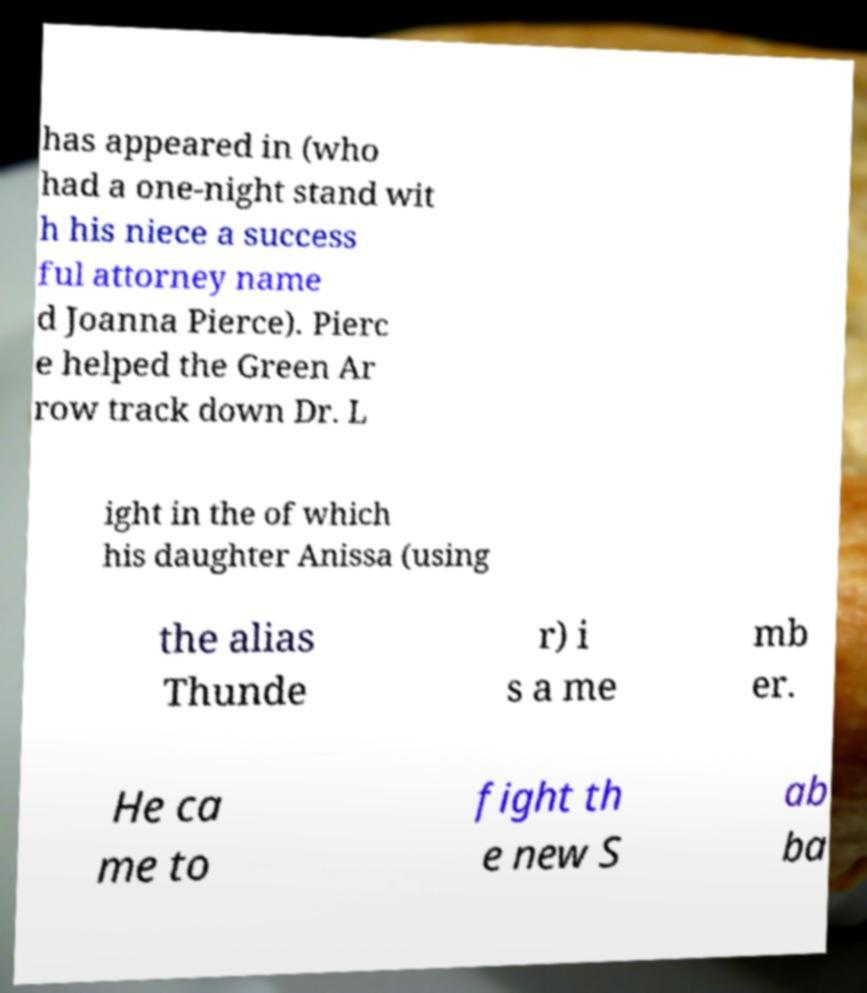Could you extract and type out the text from this image? has appeared in (who had a one-night stand wit h his niece a success ful attorney name d Joanna Pierce). Pierc e helped the Green Ar row track down Dr. L ight in the of which his daughter Anissa (using the alias Thunde r) i s a me mb er. He ca me to fight th e new S ab ba 